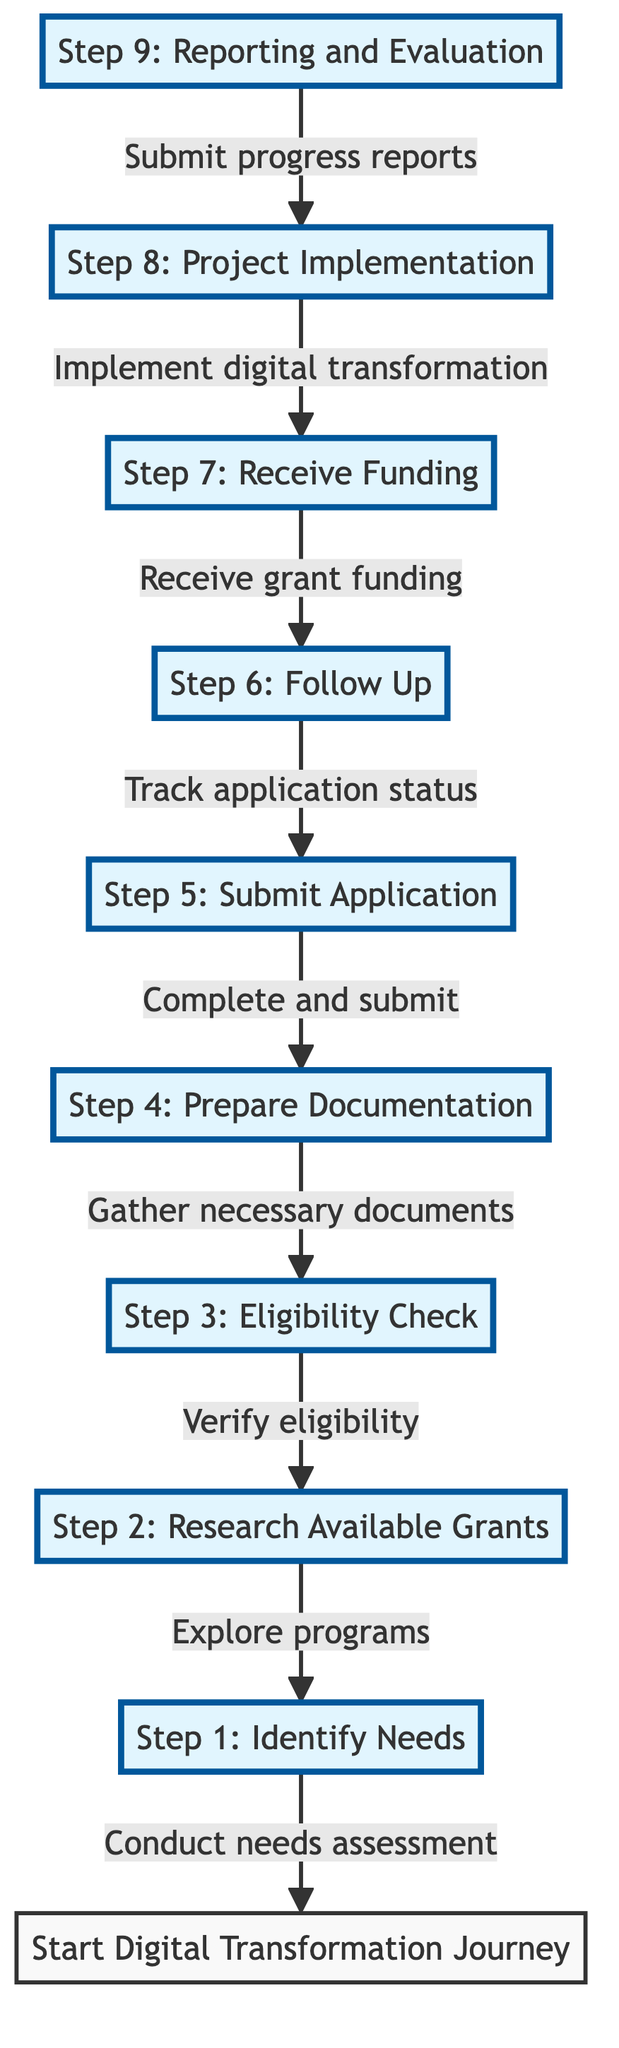What is the first step in the process? The first step listed in the diagram is "Step 1: Identify Needs," which is located at the bottom of the flow chart.
Answer: Step 1: Identify Needs How many steps are there in the process? By counting the number of nodes in the diagram, we identify a total of nine steps represented by the nodes.
Answer: 9 Which step follows "Submit Application"? In the diagram, the step that follows "Submit Application" (Step 5) is "Follow Up" (Step 6), as indicated by the direct connection between those two nodes.
Answer: Step 6: Follow Up What does "Follow Up" lead to? "Follow Up" (Step 6) leads to "Receive Funding" (Step 7) according to the arrows pointing from Step 6 to Step 7 in the diagram.
Answer: Step 7: Receive Funding What is necessary to gather for "Prepare Documentation"? The description of "Prepare Documentation" (Step 4) specifies that it involves gathering "all necessary documents." This reinforces that the main action is the collection of required documents.
Answer: All necessary documents What are the last two steps in the process? The diagram indicates that the last two steps are "Project Implementation" (Step 8) and "Reporting and Evaluation" (Step 9), which appear at the top of the flow chart in this context.
Answer: Step 8: Project Implementation and Step 9: Reporting and Evaluation Which step involves researching government programs? "Research Available Grants" (Step 2) is the step where business owners explore government programs and incentives for digital transformation, as described in its label.
Answer: Step 2: Research Available Grants What do you need to verify in "Eligibility Check"? In the "Eligibility Check" (Step 3), you need to verify your "business's eligibility" for the identified grants and programs, as highlighted in the description of that step.
Answer: Business's eligibility What is required in "Reporting and Evaluation"? In "Reporting and Evaluation" (Step 9), one of the main requirements is to submit "progress reports and evaluations" as stated in the description of this step.
Answer: Progress reports and evaluations 